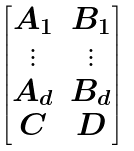<formula> <loc_0><loc_0><loc_500><loc_500>\begin{bmatrix} A _ { 1 } & B _ { 1 } \\ \vdots & \vdots \\ A _ { d } & B _ { d } \\ C & D \end{bmatrix}</formula> 